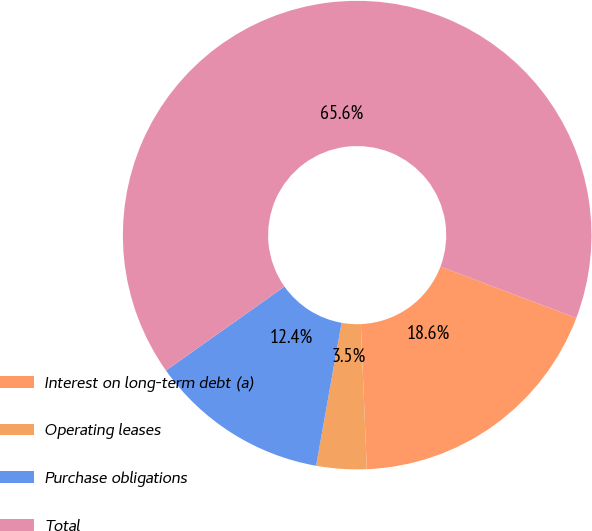Convert chart to OTSL. <chart><loc_0><loc_0><loc_500><loc_500><pie_chart><fcel>Interest on long-term debt (a)<fcel>Operating leases<fcel>Purchase obligations<fcel>Total<nl><fcel>18.59%<fcel>3.46%<fcel>12.39%<fcel>65.56%<nl></chart> 